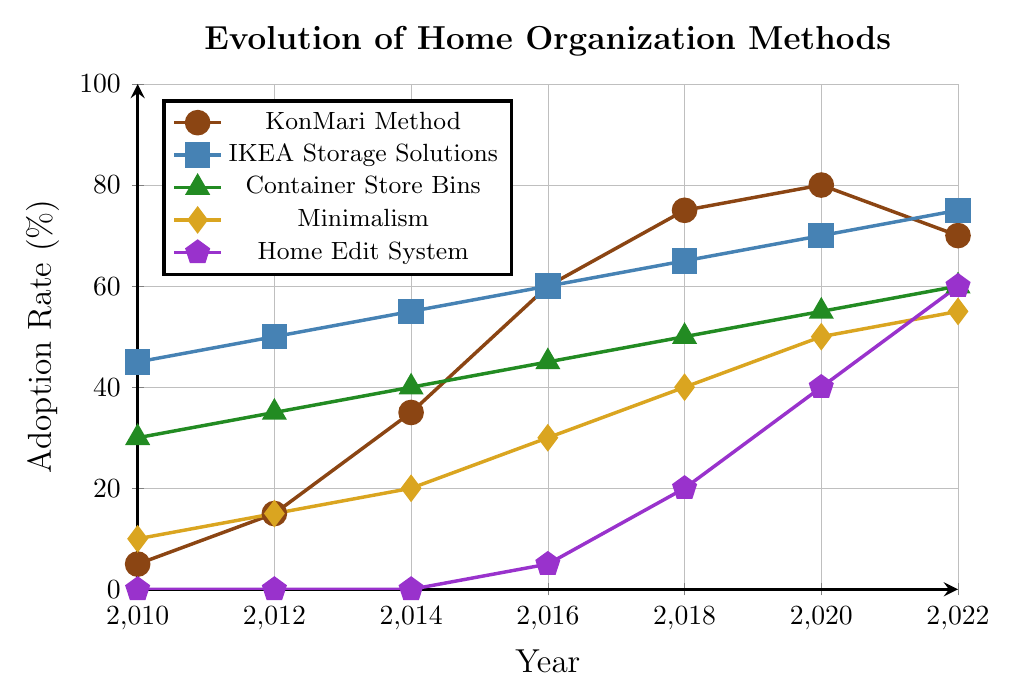What was the adoption rate of the KonMari Method in 2016? To find this, look at the KonMari Method line (marked with circles) and find the point corresponding to the year 2016. The adoption rate is 60%.
Answer: 60% Which two methods had the same adoption rate in 2016? Check the adoption rates for all methods in 2016. Both IKEA Storage Solutions and KonMari Method had adoption rates of 60%.
Answer: IKEA Storage Solutions and KonMari Method Did the adoption rate of Minimalism ever exceed 50%? Examine the Minimalism data points (marked with diamonds) over the years. In 2020 and 2022, the adoption rates were 50% and 55%, respectively, hence it did exceed 50% in 2022.
Answer: Yes, in 2022 What is the difference in adoption rate between Home Edit System and KonMari Method in 2022? Find the adoption rates for Home Edit System and KonMari Method in 2022, which are 60% and 70% respectively. The difference is 70% - 60% = 10%.
Answer: 10% Which method had the highest adoption rate in 2010? Look at all the adoption rates for the year 2010. IKEA Storage Solutions had the highest adoption rate at 45%.
Answer: IKEA Storage Solutions Which home organization method showed the greatest increase in adoption rate from 2010 to 2018? Calculate the increase for each method: KonMari Method increased from 5% to 75% (70% increase), IKEA Storage Solutions from 45% to 65% (20% increase), Container Store Bins from 30% to 50% (20% increase), Minimalism from 10% to 40% (30% increase), and Home Edit System from 0% to 20% (20% increase). KonMari Method showed the greatest increase.
Answer: KonMari Method How did the adoption rate of the Container Store Bins change from 2010 to 2022? Find the adoption rates for Container Store Bins in 2010 and 2022, which are 30% and 60% respectively. The change is 60% - 30% = 30% increase.
Answer: +30% What is the average adoption rate of the IKEA Storage Solutions in the years given? Sum the adoption rates for IKEA Storage Solutions over the years (45 + 50 + 55 + 60 + 65 + 70 + 75 = 420) and divide by the number of data points (7). 420 / 7 = 60%.
Answer: 60% By how much did the adoption rate of the Home Edit System increase from 2016 to 2022? Find the adoption rates for Home Edit System in 2016 and 2022, which are 5% and 60% respectively. The increase is 60% - 5% = 55%.
Answer: 55% 